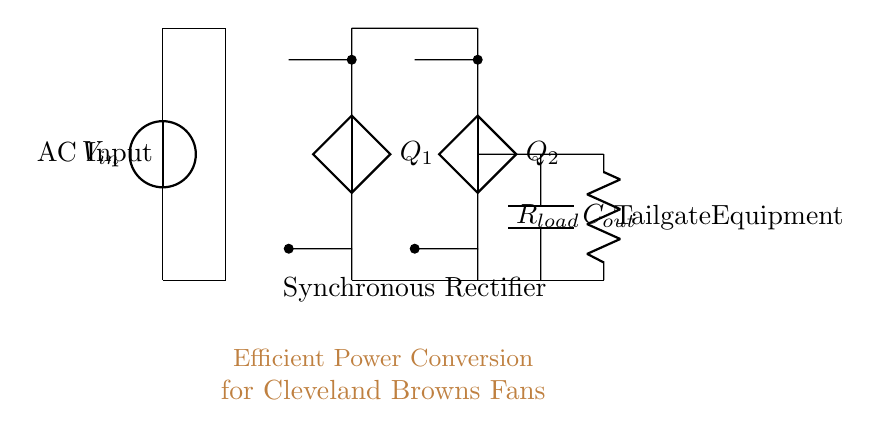What are the main components of the circuit? The main components visible in the circuit include a voltage source, a transformer, synchronous rectifiers labeled Q1 and Q2, a capacitor labeled Cout, and a load resistor labeled Rload.
Answer: Voltage source, transformer, Q1, Q2, Cout, Rload What is the purpose of the transformer in this circuit? The transformer is used to step the input AC voltage up or down to a desired level before it is rectified. It ensures the voltage matches the requirements of the synchronous rectifier part of the circuit.
Answer: Voltage adjustment What type of rectification is utilized in this circuit? The circuit employs synchronous rectification, as indicated by the components labeled Q1 and Q2, which are usually represented as controlled switches for improved efficiency compared to traditional diodes.
Answer: Synchronous rectification How does the output capacitor support the circuit? The capacitor Cout serves to smooth the output voltage by filtering out fluctuations after rectification, thus providing a more stable DC output to the load.
Answer: Smoothing output voltage What is the role of the load resistor in this circuit? The load resistor Rload represents the load connected to the power supply, consuming power and providing a path for current after rectification, which is essential for assessing the circuit's performance.
Answer: Load connection What is the significance of using synchronous rectifiers over diodes? Synchronous rectifiers reduce conduction losses by utilizing controlled switching rather than standard diodes, leading to improved efficiency, especially in low-voltage applications such as portable equipment.
Answer: Increased efficiency What might happen if the transformer was bypassed in this circuit? Bypassing the transformer would directly connect the voltage source to the synchronous rectifier, which could lead to improper voltage levels for the rectification process, potentially damaging the components and leading to inefficient operation.
Answer: Improper voltage levels 